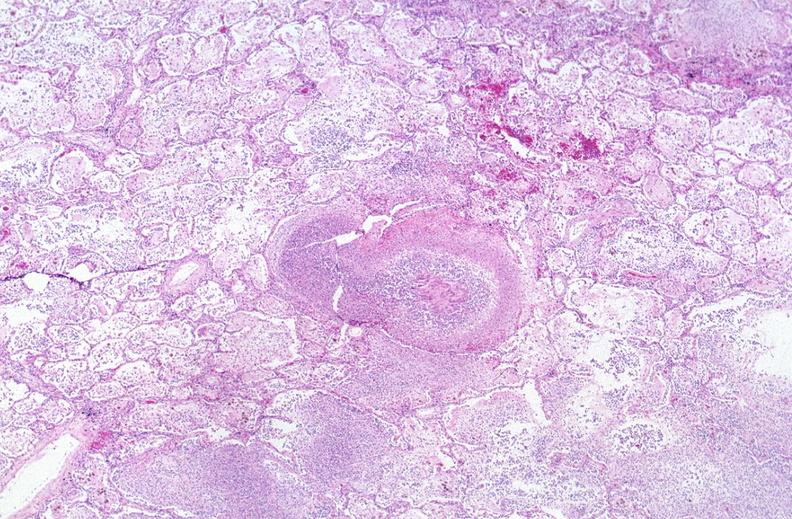what does this image show?
Answer the question using a single word or phrase. Lung 